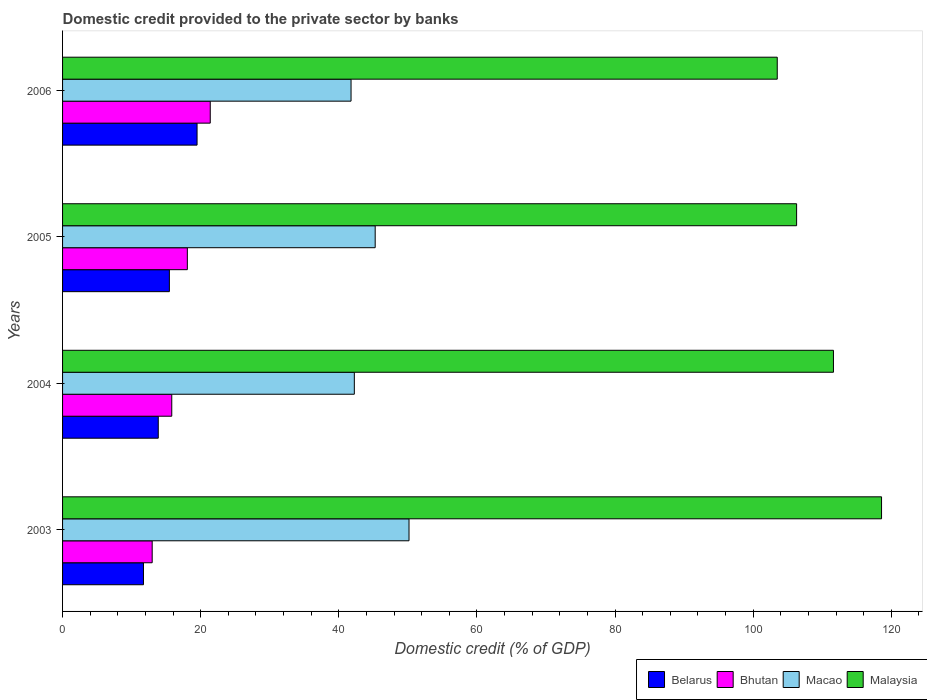How many different coloured bars are there?
Make the answer very short. 4. Are the number of bars per tick equal to the number of legend labels?
Your answer should be compact. Yes. How many bars are there on the 1st tick from the top?
Provide a short and direct response. 4. How many bars are there on the 4th tick from the bottom?
Provide a short and direct response. 4. What is the label of the 2nd group of bars from the top?
Provide a succinct answer. 2005. In how many cases, is the number of bars for a given year not equal to the number of legend labels?
Make the answer very short. 0. What is the domestic credit provided to the private sector by banks in Malaysia in 2006?
Your answer should be compact. 103.49. Across all years, what is the maximum domestic credit provided to the private sector by banks in Malaysia?
Your answer should be very brief. 118.59. Across all years, what is the minimum domestic credit provided to the private sector by banks in Bhutan?
Ensure brevity in your answer.  12.98. What is the total domestic credit provided to the private sector by banks in Malaysia in the graph?
Keep it short and to the point. 440. What is the difference between the domestic credit provided to the private sector by banks in Malaysia in 2004 and that in 2006?
Ensure brevity in your answer.  8.14. What is the difference between the domestic credit provided to the private sector by banks in Belarus in 2006 and the domestic credit provided to the private sector by banks in Malaysia in 2003?
Offer a terse response. -99.12. What is the average domestic credit provided to the private sector by banks in Macao per year?
Your response must be concise. 44.86. In the year 2004, what is the difference between the domestic credit provided to the private sector by banks in Macao and domestic credit provided to the private sector by banks in Belarus?
Give a very brief answer. 28.39. In how many years, is the domestic credit provided to the private sector by banks in Belarus greater than 116 %?
Provide a succinct answer. 0. What is the ratio of the domestic credit provided to the private sector by banks in Macao in 2005 to that in 2006?
Your answer should be very brief. 1.08. Is the domestic credit provided to the private sector by banks in Belarus in 2003 less than that in 2005?
Your answer should be very brief. Yes. Is the difference between the domestic credit provided to the private sector by banks in Macao in 2003 and 2004 greater than the difference between the domestic credit provided to the private sector by banks in Belarus in 2003 and 2004?
Provide a short and direct response. Yes. What is the difference between the highest and the second highest domestic credit provided to the private sector by banks in Bhutan?
Provide a short and direct response. 3.32. What is the difference between the highest and the lowest domestic credit provided to the private sector by banks in Macao?
Provide a short and direct response. 8.39. In how many years, is the domestic credit provided to the private sector by banks in Malaysia greater than the average domestic credit provided to the private sector by banks in Malaysia taken over all years?
Offer a very short reply. 2. What does the 1st bar from the top in 2005 represents?
Offer a terse response. Malaysia. What does the 2nd bar from the bottom in 2006 represents?
Keep it short and to the point. Bhutan. How many bars are there?
Offer a terse response. 16. Are all the bars in the graph horizontal?
Your response must be concise. Yes. Does the graph contain any zero values?
Ensure brevity in your answer.  No. Does the graph contain grids?
Offer a terse response. No. Where does the legend appear in the graph?
Offer a very short reply. Bottom right. How many legend labels are there?
Offer a very short reply. 4. What is the title of the graph?
Make the answer very short. Domestic credit provided to the private sector by banks. Does "Iraq" appear as one of the legend labels in the graph?
Provide a short and direct response. No. What is the label or title of the X-axis?
Provide a succinct answer. Domestic credit (% of GDP). What is the Domestic credit (% of GDP) in Belarus in 2003?
Provide a short and direct response. 11.71. What is the Domestic credit (% of GDP) of Bhutan in 2003?
Provide a short and direct response. 12.98. What is the Domestic credit (% of GDP) in Macao in 2003?
Offer a very short reply. 50.17. What is the Domestic credit (% of GDP) in Malaysia in 2003?
Your answer should be very brief. 118.59. What is the Domestic credit (% of GDP) of Belarus in 2004?
Provide a succinct answer. 13.86. What is the Domestic credit (% of GDP) of Bhutan in 2004?
Ensure brevity in your answer.  15.81. What is the Domestic credit (% of GDP) of Macao in 2004?
Your answer should be very brief. 42.25. What is the Domestic credit (% of GDP) of Malaysia in 2004?
Provide a short and direct response. 111.63. What is the Domestic credit (% of GDP) in Belarus in 2005?
Your response must be concise. 15.47. What is the Domestic credit (% of GDP) of Bhutan in 2005?
Your answer should be compact. 18.07. What is the Domestic credit (% of GDP) in Macao in 2005?
Your response must be concise. 45.27. What is the Domestic credit (% of GDP) of Malaysia in 2005?
Provide a succinct answer. 106.29. What is the Domestic credit (% of GDP) in Belarus in 2006?
Your answer should be very brief. 19.48. What is the Domestic credit (% of GDP) in Bhutan in 2006?
Give a very brief answer. 21.39. What is the Domestic credit (% of GDP) of Macao in 2006?
Provide a succinct answer. 41.77. What is the Domestic credit (% of GDP) in Malaysia in 2006?
Your response must be concise. 103.49. Across all years, what is the maximum Domestic credit (% of GDP) in Belarus?
Offer a very short reply. 19.48. Across all years, what is the maximum Domestic credit (% of GDP) in Bhutan?
Make the answer very short. 21.39. Across all years, what is the maximum Domestic credit (% of GDP) of Macao?
Offer a very short reply. 50.17. Across all years, what is the maximum Domestic credit (% of GDP) in Malaysia?
Provide a short and direct response. 118.59. Across all years, what is the minimum Domestic credit (% of GDP) of Belarus?
Your answer should be compact. 11.71. Across all years, what is the minimum Domestic credit (% of GDP) of Bhutan?
Your answer should be compact. 12.98. Across all years, what is the minimum Domestic credit (% of GDP) of Macao?
Give a very brief answer. 41.77. Across all years, what is the minimum Domestic credit (% of GDP) of Malaysia?
Give a very brief answer. 103.49. What is the total Domestic credit (% of GDP) in Belarus in the graph?
Provide a short and direct response. 60.52. What is the total Domestic credit (% of GDP) in Bhutan in the graph?
Offer a terse response. 68.24. What is the total Domestic credit (% of GDP) in Macao in the graph?
Give a very brief answer. 179.46. What is the total Domestic credit (% of GDP) of Malaysia in the graph?
Your answer should be compact. 440. What is the difference between the Domestic credit (% of GDP) in Belarus in 2003 and that in 2004?
Ensure brevity in your answer.  -2.14. What is the difference between the Domestic credit (% of GDP) of Bhutan in 2003 and that in 2004?
Your answer should be very brief. -2.83. What is the difference between the Domestic credit (% of GDP) in Macao in 2003 and that in 2004?
Your answer should be very brief. 7.92. What is the difference between the Domestic credit (% of GDP) of Malaysia in 2003 and that in 2004?
Offer a very short reply. 6.96. What is the difference between the Domestic credit (% of GDP) in Belarus in 2003 and that in 2005?
Make the answer very short. -3.75. What is the difference between the Domestic credit (% of GDP) in Bhutan in 2003 and that in 2005?
Offer a very short reply. -5.09. What is the difference between the Domestic credit (% of GDP) in Macao in 2003 and that in 2005?
Provide a succinct answer. 4.9. What is the difference between the Domestic credit (% of GDP) in Malaysia in 2003 and that in 2005?
Your response must be concise. 12.3. What is the difference between the Domestic credit (% of GDP) of Belarus in 2003 and that in 2006?
Make the answer very short. -7.76. What is the difference between the Domestic credit (% of GDP) of Bhutan in 2003 and that in 2006?
Provide a short and direct response. -8.41. What is the difference between the Domestic credit (% of GDP) in Macao in 2003 and that in 2006?
Offer a terse response. 8.39. What is the difference between the Domestic credit (% of GDP) in Malaysia in 2003 and that in 2006?
Ensure brevity in your answer.  15.1. What is the difference between the Domestic credit (% of GDP) of Belarus in 2004 and that in 2005?
Make the answer very short. -1.61. What is the difference between the Domestic credit (% of GDP) in Bhutan in 2004 and that in 2005?
Give a very brief answer. -2.26. What is the difference between the Domestic credit (% of GDP) of Macao in 2004 and that in 2005?
Offer a very short reply. -3.02. What is the difference between the Domestic credit (% of GDP) of Malaysia in 2004 and that in 2005?
Your answer should be compact. 5.34. What is the difference between the Domestic credit (% of GDP) in Belarus in 2004 and that in 2006?
Provide a succinct answer. -5.62. What is the difference between the Domestic credit (% of GDP) in Bhutan in 2004 and that in 2006?
Offer a very short reply. -5.57. What is the difference between the Domestic credit (% of GDP) in Macao in 2004 and that in 2006?
Your response must be concise. 0.48. What is the difference between the Domestic credit (% of GDP) of Malaysia in 2004 and that in 2006?
Your answer should be compact. 8.14. What is the difference between the Domestic credit (% of GDP) of Belarus in 2005 and that in 2006?
Your response must be concise. -4.01. What is the difference between the Domestic credit (% of GDP) of Bhutan in 2005 and that in 2006?
Ensure brevity in your answer.  -3.32. What is the difference between the Domestic credit (% of GDP) in Macao in 2005 and that in 2006?
Provide a succinct answer. 3.5. What is the difference between the Domestic credit (% of GDP) in Malaysia in 2005 and that in 2006?
Ensure brevity in your answer.  2.8. What is the difference between the Domestic credit (% of GDP) of Belarus in 2003 and the Domestic credit (% of GDP) of Bhutan in 2004?
Make the answer very short. -4.1. What is the difference between the Domestic credit (% of GDP) in Belarus in 2003 and the Domestic credit (% of GDP) in Macao in 2004?
Provide a short and direct response. -30.53. What is the difference between the Domestic credit (% of GDP) in Belarus in 2003 and the Domestic credit (% of GDP) in Malaysia in 2004?
Provide a succinct answer. -99.91. What is the difference between the Domestic credit (% of GDP) of Bhutan in 2003 and the Domestic credit (% of GDP) of Macao in 2004?
Make the answer very short. -29.27. What is the difference between the Domestic credit (% of GDP) of Bhutan in 2003 and the Domestic credit (% of GDP) of Malaysia in 2004?
Offer a very short reply. -98.65. What is the difference between the Domestic credit (% of GDP) in Macao in 2003 and the Domestic credit (% of GDP) in Malaysia in 2004?
Your response must be concise. -61.46. What is the difference between the Domestic credit (% of GDP) of Belarus in 2003 and the Domestic credit (% of GDP) of Bhutan in 2005?
Give a very brief answer. -6.35. What is the difference between the Domestic credit (% of GDP) in Belarus in 2003 and the Domestic credit (% of GDP) in Macao in 2005?
Offer a very short reply. -33.55. What is the difference between the Domestic credit (% of GDP) in Belarus in 2003 and the Domestic credit (% of GDP) in Malaysia in 2005?
Offer a very short reply. -94.58. What is the difference between the Domestic credit (% of GDP) of Bhutan in 2003 and the Domestic credit (% of GDP) of Macao in 2005?
Keep it short and to the point. -32.29. What is the difference between the Domestic credit (% of GDP) of Bhutan in 2003 and the Domestic credit (% of GDP) of Malaysia in 2005?
Give a very brief answer. -93.32. What is the difference between the Domestic credit (% of GDP) of Macao in 2003 and the Domestic credit (% of GDP) of Malaysia in 2005?
Provide a succinct answer. -56.13. What is the difference between the Domestic credit (% of GDP) of Belarus in 2003 and the Domestic credit (% of GDP) of Bhutan in 2006?
Offer a very short reply. -9.67. What is the difference between the Domestic credit (% of GDP) of Belarus in 2003 and the Domestic credit (% of GDP) of Macao in 2006?
Make the answer very short. -30.06. What is the difference between the Domestic credit (% of GDP) in Belarus in 2003 and the Domestic credit (% of GDP) in Malaysia in 2006?
Keep it short and to the point. -91.77. What is the difference between the Domestic credit (% of GDP) in Bhutan in 2003 and the Domestic credit (% of GDP) in Macao in 2006?
Provide a short and direct response. -28.79. What is the difference between the Domestic credit (% of GDP) in Bhutan in 2003 and the Domestic credit (% of GDP) in Malaysia in 2006?
Your response must be concise. -90.51. What is the difference between the Domestic credit (% of GDP) in Macao in 2003 and the Domestic credit (% of GDP) in Malaysia in 2006?
Provide a succinct answer. -53.32. What is the difference between the Domestic credit (% of GDP) of Belarus in 2004 and the Domestic credit (% of GDP) of Bhutan in 2005?
Your response must be concise. -4.21. What is the difference between the Domestic credit (% of GDP) of Belarus in 2004 and the Domestic credit (% of GDP) of Macao in 2005?
Your response must be concise. -31.41. What is the difference between the Domestic credit (% of GDP) in Belarus in 2004 and the Domestic credit (% of GDP) in Malaysia in 2005?
Ensure brevity in your answer.  -92.43. What is the difference between the Domestic credit (% of GDP) of Bhutan in 2004 and the Domestic credit (% of GDP) of Macao in 2005?
Make the answer very short. -29.46. What is the difference between the Domestic credit (% of GDP) of Bhutan in 2004 and the Domestic credit (% of GDP) of Malaysia in 2005?
Provide a succinct answer. -90.48. What is the difference between the Domestic credit (% of GDP) in Macao in 2004 and the Domestic credit (% of GDP) in Malaysia in 2005?
Offer a very short reply. -64.04. What is the difference between the Domestic credit (% of GDP) in Belarus in 2004 and the Domestic credit (% of GDP) in Bhutan in 2006?
Your answer should be very brief. -7.53. What is the difference between the Domestic credit (% of GDP) of Belarus in 2004 and the Domestic credit (% of GDP) of Macao in 2006?
Offer a terse response. -27.91. What is the difference between the Domestic credit (% of GDP) of Belarus in 2004 and the Domestic credit (% of GDP) of Malaysia in 2006?
Offer a terse response. -89.63. What is the difference between the Domestic credit (% of GDP) in Bhutan in 2004 and the Domestic credit (% of GDP) in Macao in 2006?
Provide a short and direct response. -25.96. What is the difference between the Domestic credit (% of GDP) of Bhutan in 2004 and the Domestic credit (% of GDP) of Malaysia in 2006?
Provide a succinct answer. -87.68. What is the difference between the Domestic credit (% of GDP) in Macao in 2004 and the Domestic credit (% of GDP) in Malaysia in 2006?
Your answer should be compact. -61.24. What is the difference between the Domestic credit (% of GDP) of Belarus in 2005 and the Domestic credit (% of GDP) of Bhutan in 2006?
Provide a short and direct response. -5.92. What is the difference between the Domestic credit (% of GDP) in Belarus in 2005 and the Domestic credit (% of GDP) in Macao in 2006?
Make the answer very short. -26.31. What is the difference between the Domestic credit (% of GDP) in Belarus in 2005 and the Domestic credit (% of GDP) in Malaysia in 2006?
Keep it short and to the point. -88.02. What is the difference between the Domestic credit (% of GDP) of Bhutan in 2005 and the Domestic credit (% of GDP) of Macao in 2006?
Keep it short and to the point. -23.7. What is the difference between the Domestic credit (% of GDP) in Bhutan in 2005 and the Domestic credit (% of GDP) in Malaysia in 2006?
Your answer should be compact. -85.42. What is the difference between the Domestic credit (% of GDP) in Macao in 2005 and the Domestic credit (% of GDP) in Malaysia in 2006?
Ensure brevity in your answer.  -58.22. What is the average Domestic credit (% of GDP) of Belarus per year?
Offer a very short reply. 15.13. What is the average Domestic credit (% of GDP) in Bhutan per year?
Offer a very short reply. 17.06. What is the average Domestic credit (% of GDP) of Macao per year?
Your answer should be compact. 44.86. What is the average Domestic credit (% of GDP) in Malaysia per year?
Give a very brief answer. 110. In the year 2003, what is the difference between the Domestic credit (% of GDP) in Belarus and Domestic credit (% of GDP) in Bhutan?
Your answer should be very brief. -1.26. In the year 2003, what is the difference between the Domestic credit (% of GDP) of Belarus and Domestic credit (% of GDP) of Macao?
Your response must be concise. -38.45. In the year 2003, what is the difference between the Domestic credit (% of GDP) in Belarus and Domestic credit (% of GDP) in Malaysia?
Ensure brevity in your answer.  -106.88. In the year 2003, what is the difference between the Domestic credit (% of GDP) in Bhutan and Domestic credit (% of GDP) in Macao?
Your answer should be compact. -37.19. In the year 2003, what is the difference between the Domestic credit (% of GDP) of Bhutan and Domestic credit (% of GDP) of Malaysia?
Keep it short and to the point. -105.61. In the year 2003, what is the difference between the Domestic credit (% of GDP) in Macao and Domestic credit (% of GDP) in Malaysia?
Keep it short and to the point. -68.42. In the year 2004, what is the difference between the Domestic credit (% of GDP) in Belarus and Domestic credit (% of GDP) in Bhutan?
Provide a short and direct response. -1.95. In the year 2004, what is the difference between the Domestic credit (% of GDP) of Belarus and Domestic credit (% of GDP) of Macao?
Give a very brief answer. -28.39. In the year 2004, what is the difference between the Domestic credit (% of GDP) of Belarus and Domestic credit (% of GDP) of Malaysia?
Your answer should be very brief. -97.77. In the year 2004, what is the difference between the Domestic credit (% of GDP) in Bhutan and Domestic credit (% of GDP) in Macao?
Your answer should be compact. -26.44. In the year 2004, what is the difference between the Domestic credit (% of GDP) in Bhutan and Domestic credit (% of GDP) in Malaysia?
Provide a short and direct response. -95.82. In the year 2004, what is the difference between the Domestic credit (% of GDP) in Macao and Domestic credit (% of GDP) in Malaysia?
Ensure brevity in your answer.  -69.38. In the year 2005, what is the difference between the Domestic credit (% of GDP) in Belarus and Domestic credit (% of GDP) in Bhutan?
Ensure brevity in your answer.  -2.6. In the year 2005, what is the difference between the Domestic credit (% of GDP) of Belarus and Domestic credit (% of GDP) of Macao?
Provide a succinct answer. -29.8. In the year 2005, what is the difference between the Domestic credit (% of GDP) of Belarus and Domestic credit (% of GDP) of Malaysia?
Provide a short and direct response. -90.83. In the year 2005, what is the difference between the Domestic credit (% of GDP) of Bhutan and Domestic credit (% of GDP) of Macao?
Your answer should be compact. -27.2. In the year 2005, what is the difference between the Domestic credit (% of GDP) of Bhutan and Domestic credit (% of GDP) of Malaysia?
Your response must be concise. -88.22. In the year 2005, what is the difference between the Domestic credit (% of GDP) in Macao and Domestic credit (% of GDP) in Malaysia?
Provide a short and direct response. -61.02. In the year 2006, what is the difference between the Domestic credit (% of GDP) of Belarus and Domestic credit (% of GDP) of Bhutan?
Make the answer very short. -1.91. In the year 2006, what is the difference between the Domestic credit (% of GDP) in Belarus and Domestic credit (% of GDP) in Macao?
Provide a short and direct response. -22.3. In the year 2006, what is the difference between the Domestic credit (% of GDP) in Belarus and Domestic credit (% of GDP) in Malaysia?
Provide a short and direct response. -84.01. In the year 2006, what is the difference between the Domestic credit (% of GDP) of Bhutan and Domestic credit (% of GDP) of Macao?
Your answer should be very brief. -20.39. In the year 2006, what is the difference between the Domestic credit (% of GDP) in Bhutan and Domestic credit (% of GDP) in Malaysia?
Ensure brevity in your answer.  -82.1. In the year 2006, what is the difference between the Domestic credit (% of GDP) in Macao and Domestic credit (% of GDP) in Malaysia?
Offer a very short reply. -61.72. What is the ratio of the Domestic credit (% of GDP) of Belarus in 2003 to that in 2004?
Provide a succinct answer. 0.85. What is the ratio of the Domestic credit (% of GDP) of Bhutan in 2003 to that in 2004?
Ensure brevity in your answer.  0.82. What is the ratio of the Domestic credit (% of GDP) in Macao in 2003 to that in 2004?
Make the answer very short. 1.19. What is the ratio of the Domestic credit (% of GDP) of Malaysia in 2003 to that in 2004?
Your answer should be very brief. 1.06. What is the ratio of the Domestic credit (% of GDP) of Belarus in 2003 to that in 2005?
Your response must be concise. 0.76. What is the ratio of the Domestic credit (% of GDP) in Bhutan in 2003 to that in 2005?
Offer a terse response. 0.72. What is the ratio of the Domestic credit (% of GDP) of Macao in 2003 to that in 2005?
Your answer should be very brief. 1.11. What is the ratio of the Domestic credit (% of GDP) in Malaysia in 2003 to that in 2005?
Your answer should be very brief. 1.12. What is the ratio of the Domestic credit (% of GDP) in Belarus in 2003 to that in 2006?
Offer a terse response. 0.6. What is the ratio of the Domestic credit (% of GDP) in Bhutan in 2003 to that in 2006?
Offer a very short reply. 0.61. What is the ratio of the Domestic credit (% of GDP) in Macao in 2003 to that in 2006?
Provide a short and direct response. 1.2. What is the ratio of the Domestic credit (% of GDP) of Malaysia in 2003 to that in 2006?
Make the answer very short. 1.15. What is the ratio of the Domestic credit (% of GDP) of Belarus in 2004 to that in 2005?
Keep it short and to the point. 0.9. What is the ratio of the Domestic credit (% of GDP) in Bhutan in 2004 to that in 2005?
Your answer should be compact. 0.88. What is the ratio of the Domestic credit (% of GDP) of Malaysia in 2004 to that in 2005?
Offer a very short reply. 1.05. What is the ratio of the Domestic credit (% of GDP) of Belarus in 2004 to that in 2006?
Give a very brief answer. 0.71. What is the ratio of the Domestic credit (% of GDP) in Bhutan in 2004 to that in 2006?
Your answer should be very brief. 0.74. What is the ratio of the Domestic credit (% of GDP) in Macao in 2004 to that in 2006?
Your answer should be compact. 1.01. What is the ratio of the Domestic credit (% of GDP) of Malaysia in 2004 to that in 2006?
Ensure brevity in your answer.  1.08. What is the ratio of the Domestic credit (% of GDP) of Belarus in 2005 to that in 2006?
Your answer should be compact. 0.79. What is the ratio of the Domestic credit (% of GDP) of Bhutan in 2005 to that in 2006?
Give a very brief answer. 0.84. What is the ratio of the Domestic credit (% of GDP) in Macao in 2005 to that in 2006?
Give a very brief answer. 1.08. What is the ratio of the Domestic credit (% of GDP) of Malaysia in 2005 to that in 2006?
Make the answer very short. 1.03. What is the difference between the highest and the second highest Domestic credit (% of GDP) of Belarus?
Your response must be concise. 4.01. What is the difference between the highest and the second highest Domestic credit (% of GDP) in Bhutan?
Make the answer very short. 3.32. What is the difference between the highest and the second highest Domestic credit (% of GDP) in Macao?
Your answer should be compact. 4.9. What is the difference between the highest and the second highest Domestic credit (% of GDP) of Malaysia?
Your response must be concise. 6.96. What is the difference between the highest and the lowest Domestic credit (% of GDP) of Belarus?
Provide a short and direct response. 7.76. What is the difference between the highest and the lowest Domestic credit (% of GDP) of Bhutan?
Keep it short and to the point. 8.41. What is the difference between the highest and the lowest Domestic credit (% of GDP) in Macao?
Provide a short and direct response. 8.39. What is the difference between the highest and the lowest Domestic credit (% of GDP) of Malaysia?
Provide a short and direct response. 15.1. 